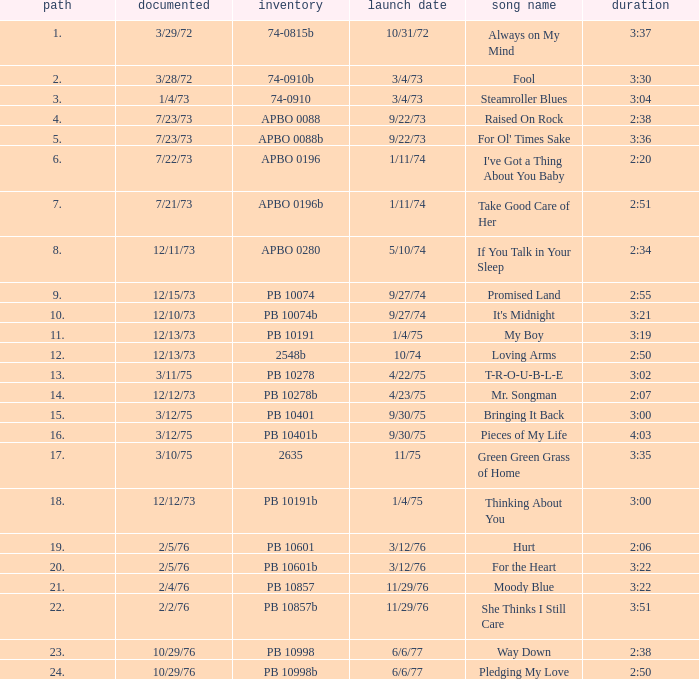I want the sum of tracks for raised on rock 4.0. 